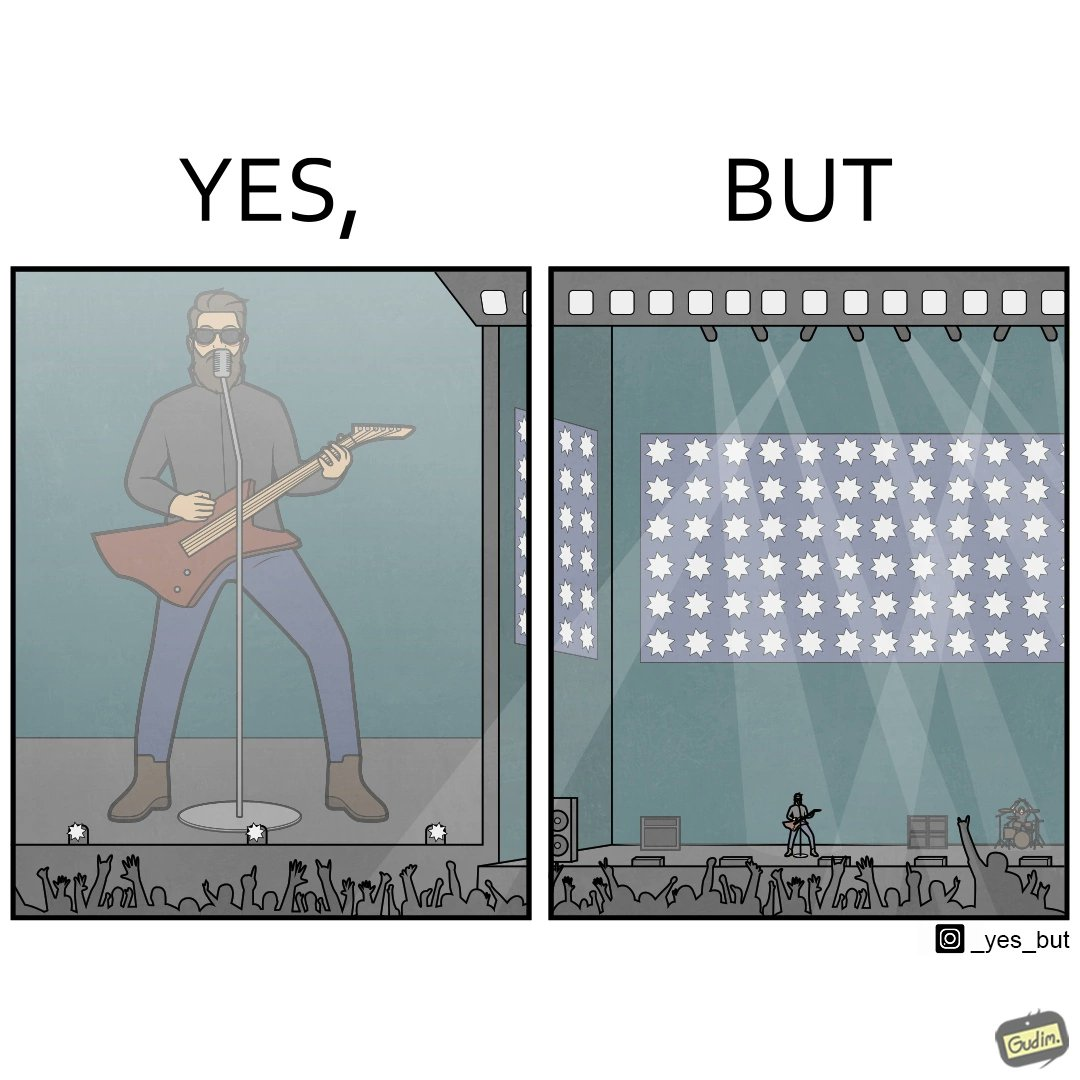What does this image depict? The image is ironic, because as the singer is performing in an orchestra but because there is so much crowd people at the back are not able to get a clear view of the singer 